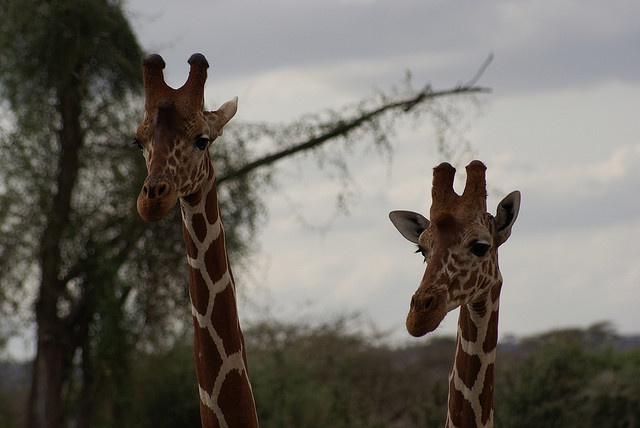Describe the objects in this image and their specific colors. I can see giraffe in black, maroon, and gray tones and giraffe in black, maroon, and gray tones in this image. 